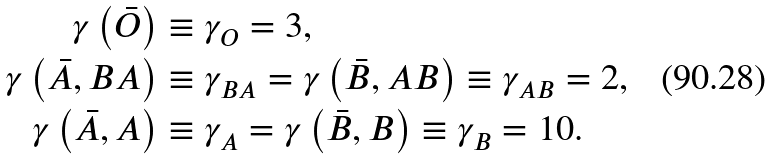Convert formula to latex. <formula><loc_0><loc_0><loc_500><loc_500>\gamma \left ( \bar { O } \right ) & \equiv \gamma _ { O } = 3 , \\ \gamma \left ( \bar { A } , B A \right ) & \equiv \gamma _ { B A } = \gamma \left ( \bar { B } , A B \right ) \equiv \gamma _ { A B } = 2 , \\ \gamma \left ( \bar { A } , A \right ) & \equiv \gamma _ { A } = \gamma \left ( \bar { B } , B \right ) \equiv \gamma _ { B } = 1 0 .</formula> 